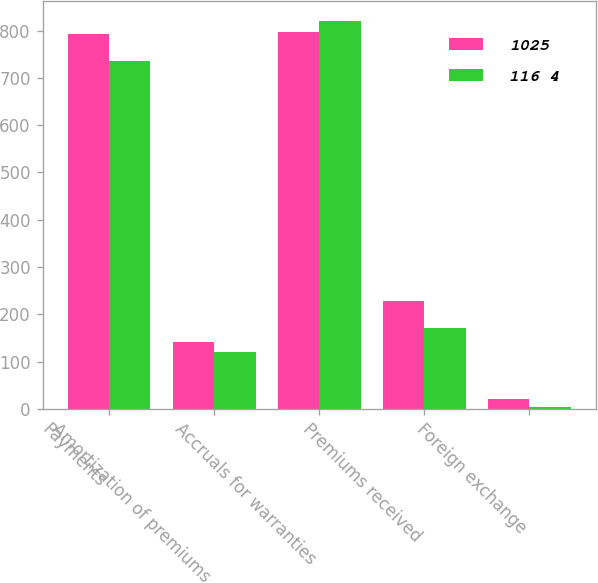Convert chart. <chart><loc_0><loc_0><loc_500><loc_500><stacked_bar_chart><ecel><fcel>Payments<fcel>Amortization of premiums<fcel>Accruals for warranties<fcel>Premiums received<fcel>Foreign exchange<nl><fcel>1025<fcel>792<fcel>142<fcel>797<fcel>228<fcel>21<nl><fcel>116 4<fcel>736<fcel>120<fcel>821<fcel>170<fcel>4<nl></chart> 